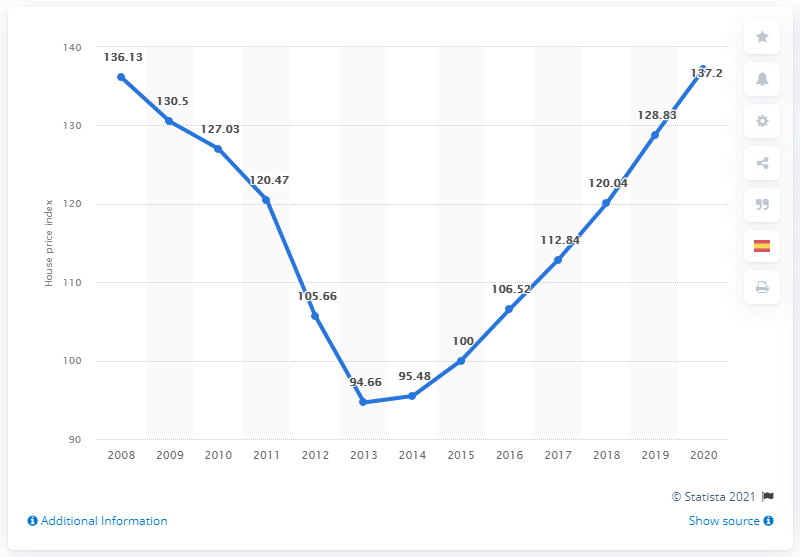Identify some key points in this picture. The index reached its peak in 2020. For a total of 5 years, the index has been above 125. 